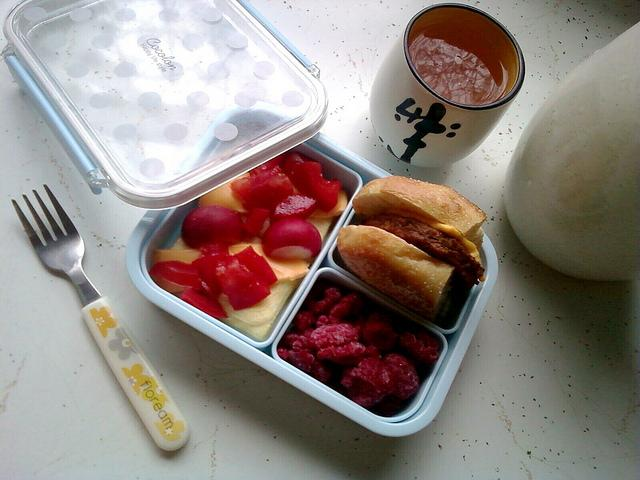What item resembles the item all the way to the left? Please explain your reasoning. pitchfork. The fork has four prongs. 